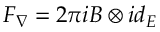Convert formula to latex. <formula><loc_0><loc_0><loc_500><loc_500>F _ { \nabla } = 2 \pi i B \otimes i d _ { E }</formula> 